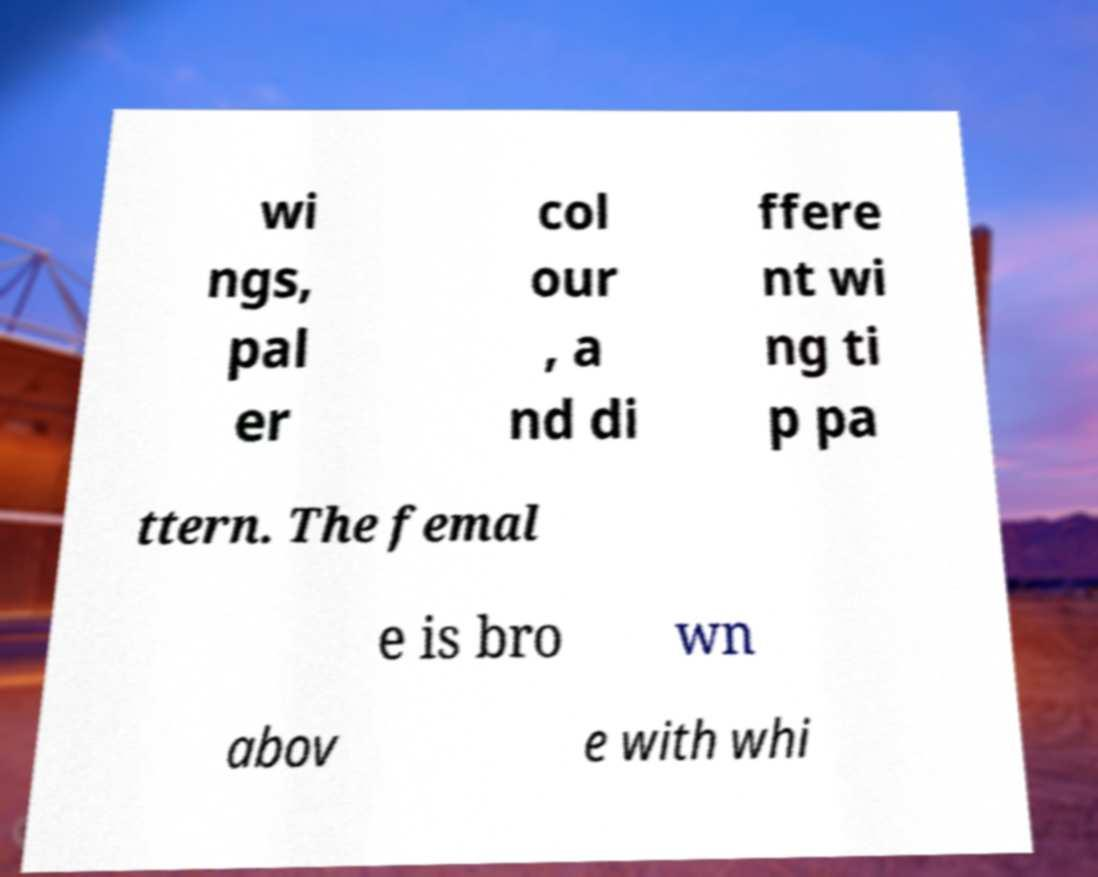Can you accurately transcribe the text from the provided image for me? wi ngs, pal er col our , a nd di ffere nt wi ng ti p pa ttern. The femal e is bro wn abov e with whi 